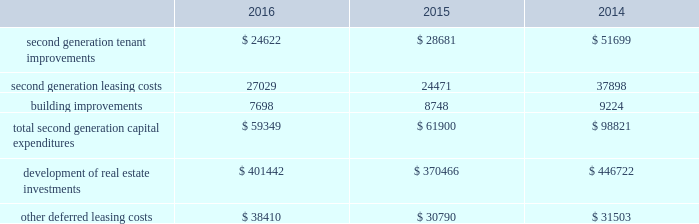Property investmentp yrr our overall strategy is to continue to increase our investment in quality industrial properties in both existing and select new markets and to continue to increase our investment in on-campus or hospital affiliated medical offf fice ff properties .
Pursuant to this strategy , we evaluate development and acquisition opportunities based upon our market yy outlook , including general economic conditions , supply and long-term growth potential .
Our ability to make future property investments is dependent upon identifying suitable acquisition and development opportunities , and our continued access to our longer-term sources of liquidity , including issuances of debt or equity securities as well asyy generating cash flow by disposing of selected properties .
Leasing/capital costsg p tenant improvements and lease-related costs pertaining to our initial leasing of newly completed space , or vacant tt space in acquired properties , are referred to as first generation expenditures .
Such first generation expenditures for tenant improvements are included within "development of real estate investments" in our consolidated statements of cash flows , while such expenditures for lease-related costs are included within "other deferred leasing costs." cash expenditures related to the construction of a building's shell , as well as the associated site improvements , are also included within "development of real estate investments" in our consolidated statements of cash flows .
Tenant improvements and leasing costs to re-let rental space that we previously leased to tenants are referred to as tt second generation expenditures .
Building improvements that are not specific to any tenant , but serve to improve integral components of our real estate properties , are also second generation expenditures .
One of the principal uses of our liquidity is to fund the second generation leasing/capital expenditures of our real estate investments .
The table summarizes our second generation capital expenditures by type of expenditure , as well as capital expenditures for the development of real estate investments and for other deferred leasing costs ( in thousands ) : .
Second generation capital expenditures were significantly lower during 2016 and 2015 , compared to 2014 , as the result of significant dispositions of office properties , which were more capital intensive to re-lease than industrial ff properties .
We had wholly owned properties under development with an expected cost of ww $ 713.1 million at december 31 , 2016 , compared to projects with an expected cost of $ 599.8 million and $ 470.2 million at december 31 , 2015 and 2014 , respectively .
The capital expenditures in the table above include the capitalization of internal overhead costs .
We capitalized ww $ 24.0 million , $ 21.7 million and $ 23.9 million of overhead costs related to leasing activities , including both first and second generation leases , during the years ended december 31 , 2016 , 2015 and 2014 , respectively .
We ww capitalized $ 25.9 million , $ 23.8 million and $ 28.8 million of overhead costs related to development activities , including both development and tenant improvement projects on first and second generation space , during the years ended december 31 , 2016 , 2015 and 2014 , respectively .
Combined overhead costs capitalized to leasing and development totaled 33.5% ( 33.5 % ) , 29.0% ( 29.0 % ) and 31.4% ( 31.4 % ) of our overall pool of overhead costs at december 31 , 2016 , 2015 and 2014 , respectively .
Further discussion of the capitalization of overhead costs can be found in the year-to-year comparisons of general and administrative expenses and critical accounting policies sections of this item 7. .
In 2015 what was the percent of the total second generation capital expenditures by type of expenditure that wassecond generation leasing costs? 
Computations: (24471 / 30790)
Answer: 0.79477. 